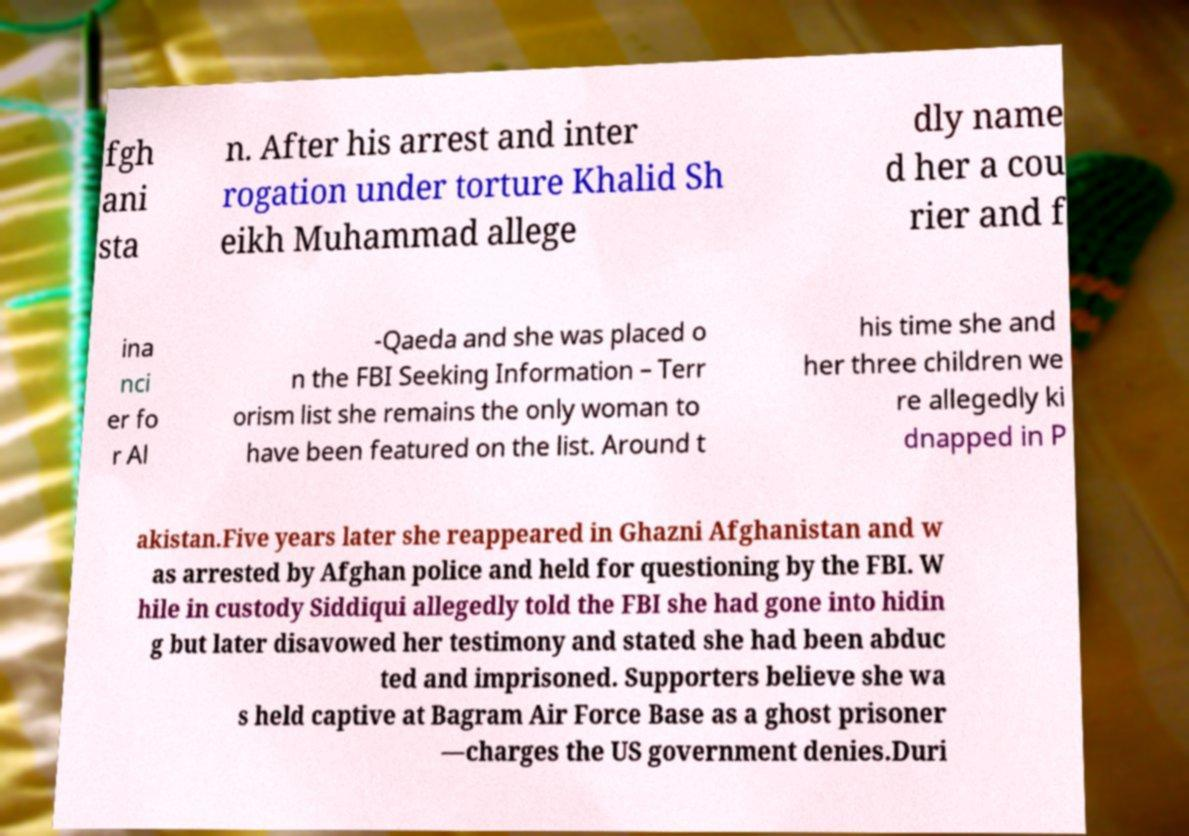Please identify and transcribe the text found in this image. fgh ani sta n. After his arrest and inter rogation under torture Khalid Sh eikh Muhammad allege dly name d her a cou rier and f ina nci er fo r Al -Qaeda and she was placed o n the FBI Seeking Information – Terr orism list she remains the only woman to have been featured on the list. Around t his time she and her three children we re allegedly ki dnapped in P akistan.Five years later she reappeared in Ghazni Afghanistan and w as arrested by Afghan police and held for questioning by the FBI. W hile in custody Siddiqui allegedly told the FBI she had gone into hidin g but later disavowed her testimony and stated she had been abduc ted and imprisoned. Supporters believe she wa s held captive at Bagram Air Force Base as a ghost prisoner —charges the US government denies.Duri 